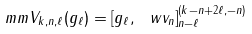Convert formula to latex. <formula><loc_0><loc_0><loc_500><loc_500>\ m m V _ { k , n , \ell } ( g _ { \ell } ) = [ g _ { \ell } , \ w v _ { n } ] _ { n - \ell } ^ { ( k - n + 2 \ell , - n ) }</formula> 